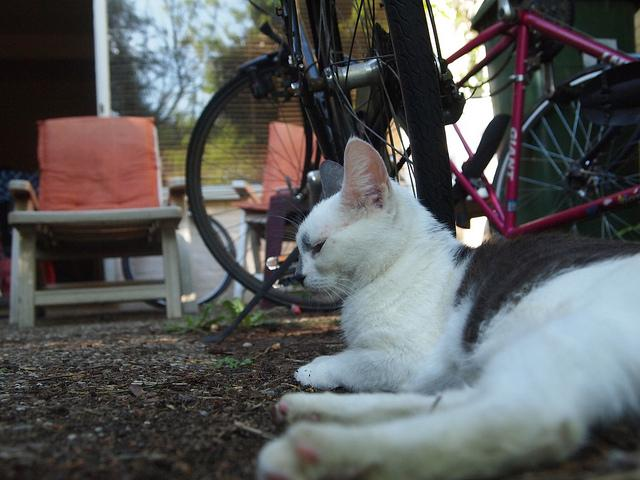What faces the most danger of getting hurt if people go to ride the bikes? Please explain your reasoning. cat. The cat is sitting very close to the bike tires and could get run over if not careful. 